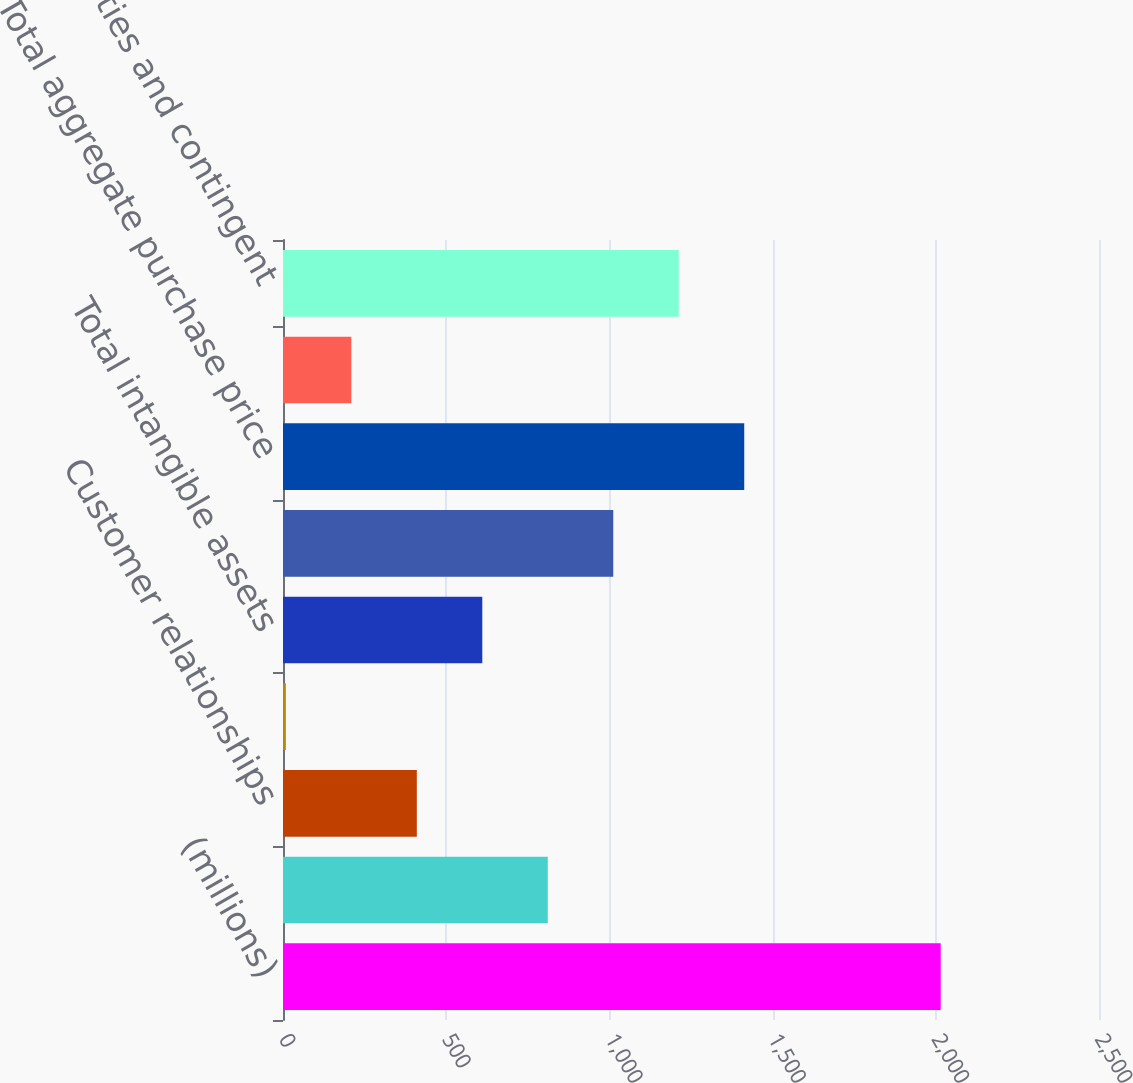<chart> <loc_0><loc_0><loc_500><loc_500><bar_chart><fcel>(millions)<fcel>Net tangible assets acquired<fcel>Customer relationships<fcel>Other technology<fcel>Total intangible assets<fcel>Goodwill<fcel>Total aggregate purchase price<fcel>Acquisition related<fcel>liabilities and contingent<nl><fcel>2015<fcel>811.22<fcel>409.96<fcel>8.7<fcel>610.59<fcel>1011.85<fcel>1413.11<fcel>209.33<fcel>1212.48<nl></chart> 